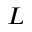Convert formula to latex. <formula><loc_0><loc_0><loc_500><loc_500>L</formula> 